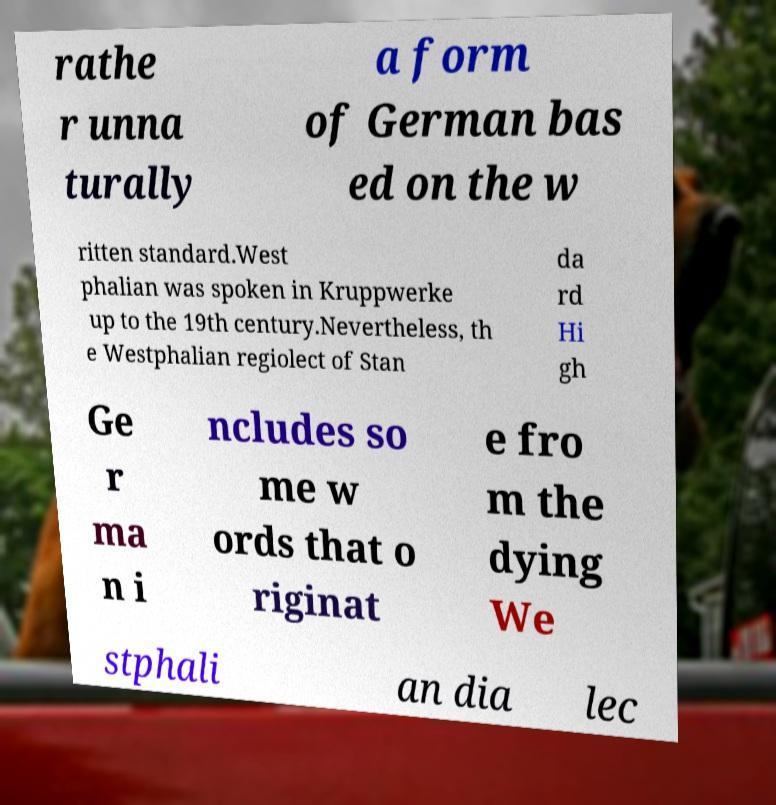Could you assist in decoding the text presented in this image and type it out clearly? rathe r unna turally a form of German bas ed on the w ritten standard.West phalian was spoken in Kruppwerke up to the 19th century.Nevertheless, th e Westphalian regiolect of Stan da rd Hi gh Ge r ma n i ncludes so me w ords that o riginat e fro m the dying We stphali an dia lec 